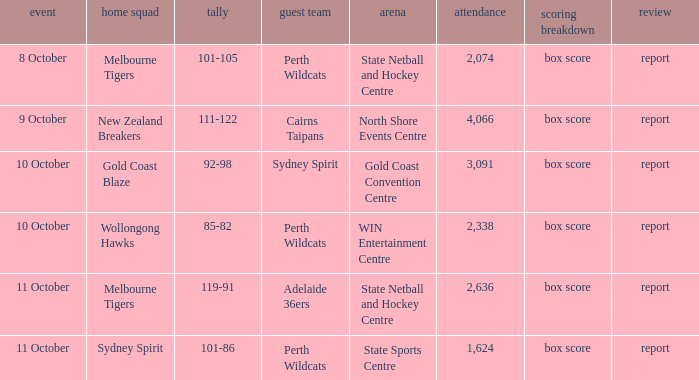What was the average crowd size for the game when the Gold Coast Blaze was the home team? 3091.0. 